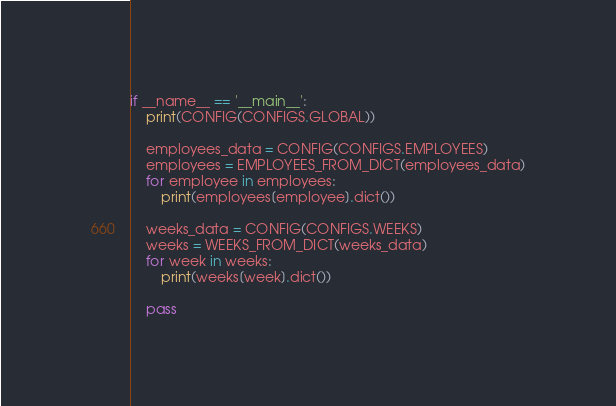Convert code to text. <code><loc_0><loc_0><loc_500><loc_500><_Python_>if __name__ == '__main__':
    print(CONFIG(CONFIGS.GLOBAL))

    employees_data = CONFIG(CONFIGS.EMPLOYEES)
    employees = EMPLOYEES_FROM_DICT(employees_data)
    for employee in employees:
        print(employees[employee].dict())

    weeks_data = CONFIG(CONFIGS.WEEKS)
    weeks = WEEKS_FROM_DICT(weeks_data)
    for week in weeks:
        print(weeks[week].dict())

    pass
</code> 